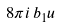<formula> <loc_0><loc_0><loc_500><loc_500>8 \pi i \, b _ { 1 } u</formula> 